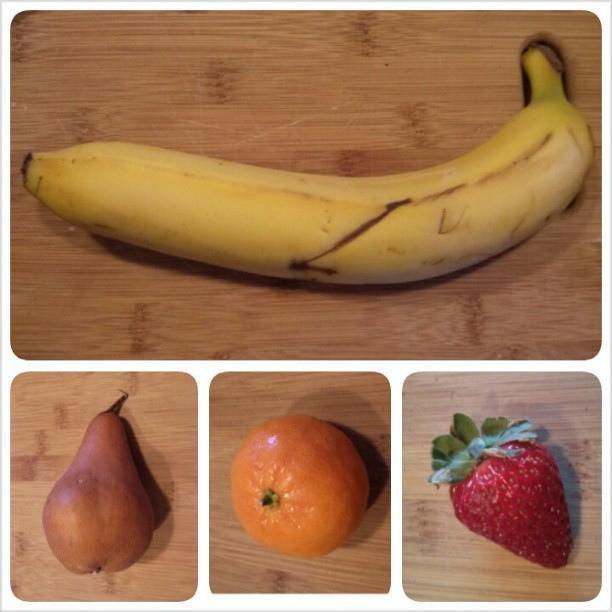How many of these need to be peeled before eating?
Give a very brief answer. 2. How many fruits are present?
Give a very brief answer. 4. How many dining tables are there?
Give a very brief answer. 3. How many people are wearing white shirts?
Give a very brief answer. 0. 